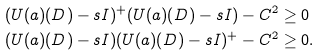<formula> <loc_0><loc_0><loc_500><loc_500>( U ( a ) ( D ) - s I ) ^ { + } ( U ( a ) ( D ) - s I ) - C ^ { 2 } & \geq 0 \\ ( U ( a ) ( D ) - s I ) ( U ( a ) ( D ) - s I ) ^ { + } - C ^ { 2 } & \geq 0 .</formula> 